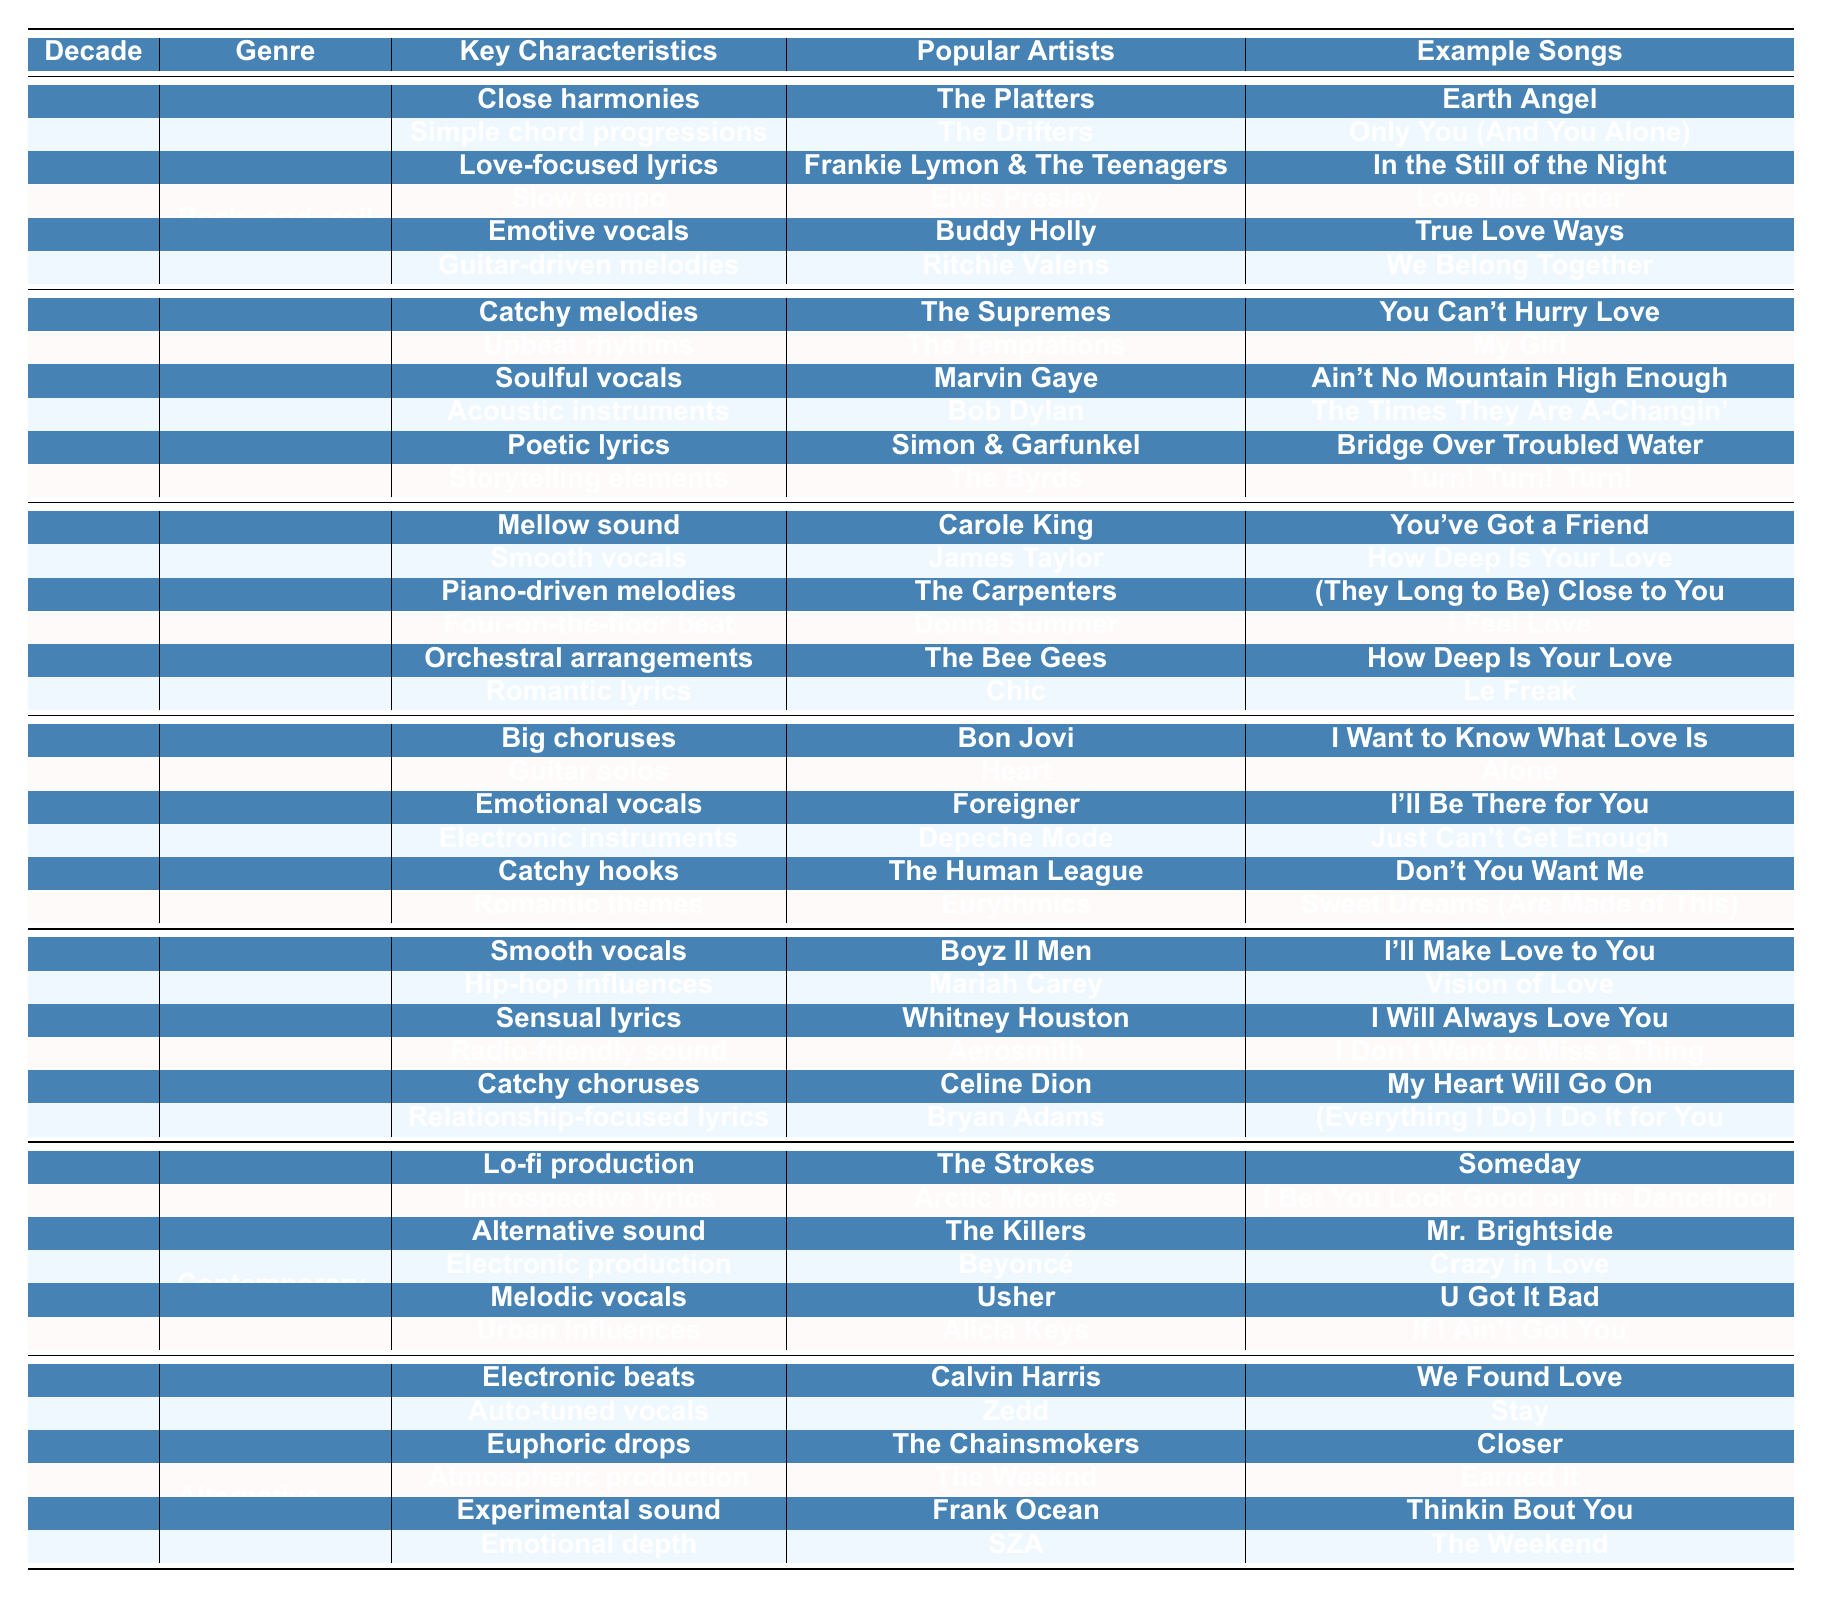What are the key characteristics of Doo-wop music? Refer to the 1950s section under the genre Doo-wop in the table, which lists the key characteristics as close harmonies, simple chord progressions, and love-focused lyrics.
Answer: Close harmonies, simple chord progressions, love-focused lyrics Which artists are associated with power ballads? Look at the 1980s section under the genre Power ballads to find popular artists listed as Bon Jovi, Heart, and Foreigner.
Answer: Bon Jovi, Heart, Foreigner What genre includes "We Found Love" as an example song? Check the 2010s section in the table to see that "We Found Love" is categorized under the genre EDM-pop.
Answer: EDM-pop In which decade did Soft rock become popular? The table shows that Soft rock is listed under the 1970s section, indicating that it became popular during that decade.
Answer: 1970s How many genres are listed for the 1990s? By counting the genres listed under the 1990s section in the table, we see that there are two genres: R&B and Pop rock.
Answer: 2 Which genre has both electronic production and melodic vocals as key characteristics? The table shows that Contemporary R&B from the 2000s has both electronic production and melodic vocals as key characteristics.
Answer: Contemporary R&B What is the main characteristic of Disco music? The table lists three key characteristics of Disco music in the 1970s: four-on-the-floor beat, orchestral arrangements, and romantic lyrics. The main characteristic can be summarized as the four-on-the-floor beat.
Answer: Four-on-the-floor beat Is "I Want to Know What Love Is" an example song from the 1950s? Checking the table, "I Want to Know What Love Is" is listed under Power ballads in the 1980s, making this statement false.
Answer: No What are the popular artists associated with Synth-pop? In the 1980s section, Synth-pop features popular artists Depeche Mode, The Human League, and Eurythmics.
Answer: Depeche Mode, The Human League, Eurythmics Which decade features "Crazy in Love" and what genre does it belong to? The table indicates that "Crazy in Love" is an example song of the genre Contemporary R&B from the 2000s.
Answer: 2000s, Contemporary R&B How do the key characteristics of Motown music compare to those of Folk rock? Motown music emphasizes catchy melodies, upbeat rhythms, and soulful vocals, while Folk rock focuses on acoustic instruments, poetic lyrics, and storytelling elements, showing a contrast in style and instrumentation.
Answer: They differ in style and instrumentation Which genre from the 1960s has a focus on storytelling elements? The table indicates that Folk rock has storytelling elements as one of its key characteristics listed in the 1960s section.
Answer: Folk rock Are there more examples of songs in the 1980s or 2000s? The 1980s has six example songs (from two genres), and the 2000s has six example songs as well (from two genres), indicating they are equal.
Answer: They are equal What are the key characteristics of Alternative R&B? Looking at the 2010s section, Alternative R&B has atmospheric production, experimental sound, and emotional depth as its key characteristics.
Answer: Atmospheric production, experimental sound, emotional depth Which genre in the 1970s shares the most example songs with Soft rock? Soft rock and Disco both have three example songs listed in the table, making them equal in that respect.
Answer: They both have three example songs 